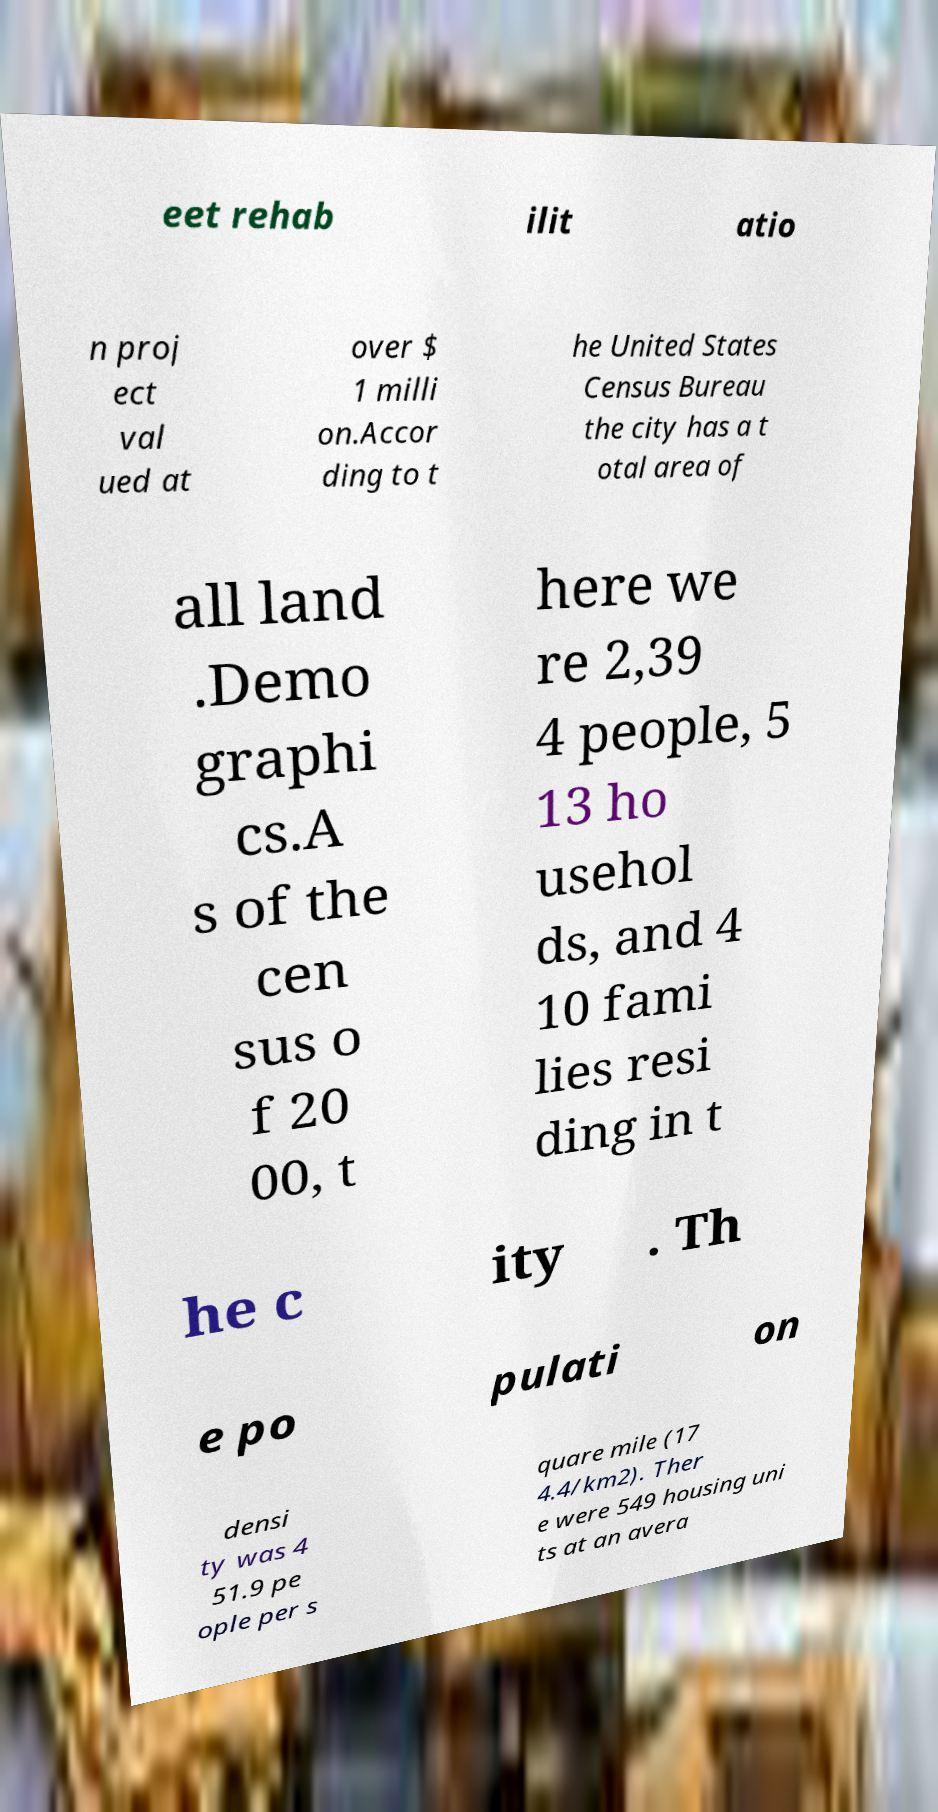Please identify and transcribe the text found in this image. eet rehab ilit atio n proj ect val ued at over $ 1 milli on.Accor ding to t he United States Census Bureau the city has a t otal area of all land .Demo graphi cs.A s of the cen sus o f 20 00, t here we re 2,39 4 people, 5 13 ho usehol ds, and 4 10 fami lies resi ding in t he c ity . Th e po pulati on densi ty was 4 51.9 pe ople per s quare mile (17 4.4/km2). Ther e were 549 housing uni ts at an avera 